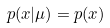Convert formula to latex. <formula><loc_0><loc_0><loc_500><loc_500>p ( x | \mu ) = p ( x )</formula> 